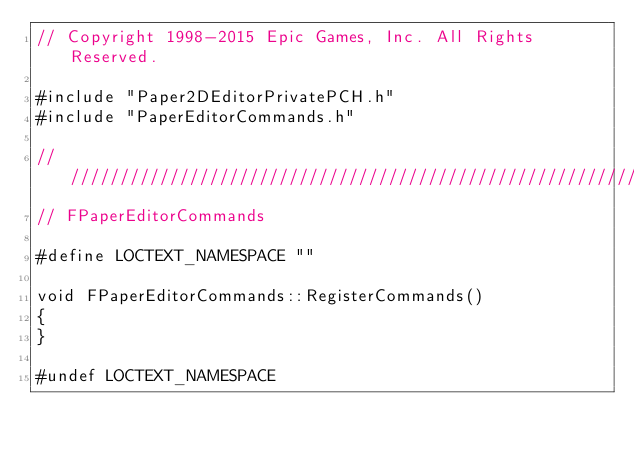<code> <loc_0><loc_0><loc_500><loc_500><_C++_>// Copyright 1998-2015 Epic Games, Inc. All Rights Reserved.

#include "Paper2DEditorPrivatePCH.h"
#include "PaperEditorCommands.h"

//////////////////////////////////////////////////////////////////////////
// FPaperEditorCommands

#define LOCTEXT_NAMESPACE ""

void FPaperEditorCommands::RegisterCommands()
{
}
	
#undef LOCTEXT_NAMESPACE</code> 